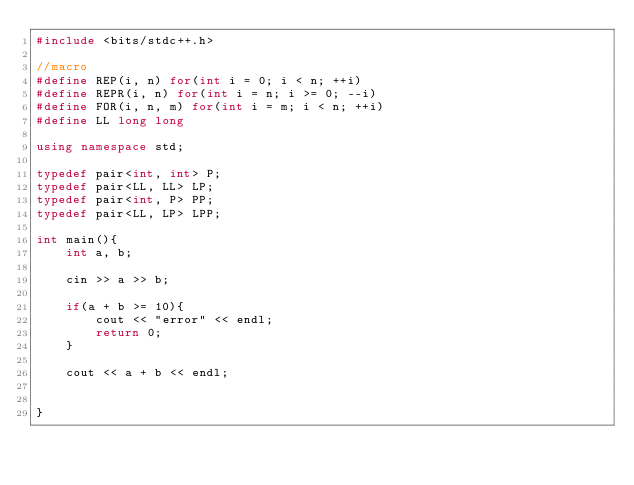<code> <loc_0><loc_0><loc_500><loc_500><_C++_>#include <bits/stdc++.h>

//macro
#define REP(i, n) for(int i = 0; i < n; ++i)
#define REPR(i, n) for(int i = n; i >= 0; --i)
#define FOR(i, n, m) for(int i = m; i < n; ++i)
#define LL long long

using namespace std;

typedef pair<int, int> P;
typedef pair<LL, LL> LP;
typedef pair<int, P> PP;
typedef pair<LL, LP> LPP;

int main(){
    int a, b;

    cin >> a >> b;

    if(a + b >= 10){
        cout << "error" << endl;
        return 0;
    }

    cout << a + b << endl;

    
}</code> 